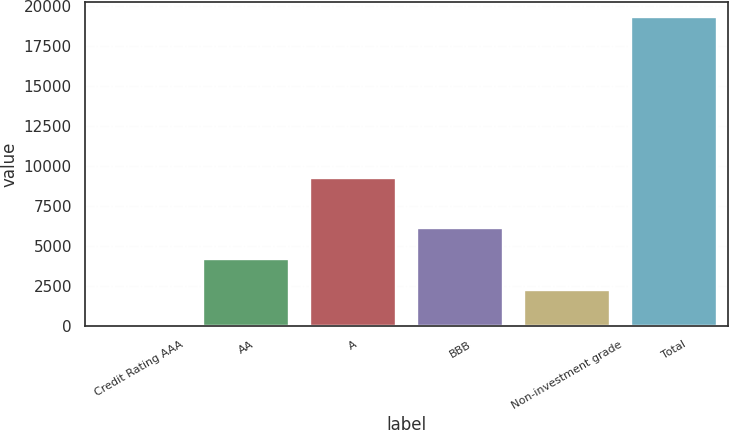<chart> <loc_0><loc_0><loc_500><loc_500><bar_chart><fcel>Credit Rating AAA<fcel>AA<fcel>A<fcel>BBB<fcel>Non-investment grade<fcel>Total<nl><fcel>150<fcel>4195.7<fcel>9244<fcel>6108.4<fcel>2283<fcel>19277<nl></chart> 